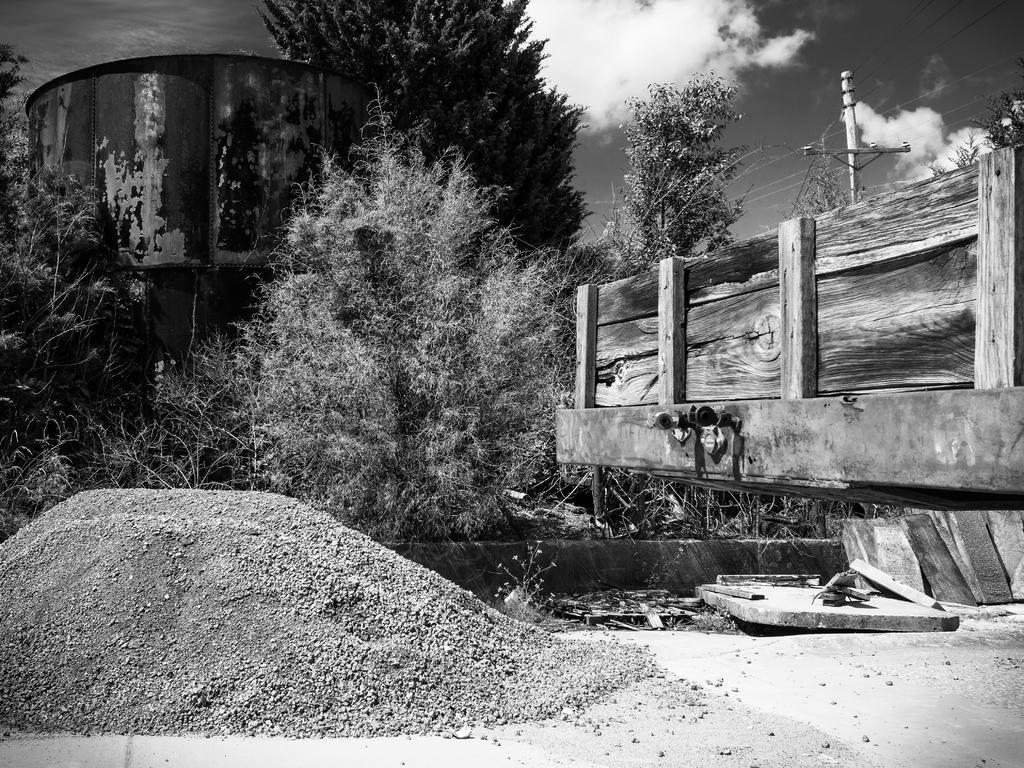Please provide a concise description of this image. This is a black and white image. In the foreground we can see the gravels and there are some objects placed on the ground. In the center we can see the wooden planks, cables, pole, trees and plants. In the background there is a sky and some object. 